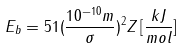Convert formula to latex. <formula><loc_0><loc_0><loc_500><loc_500>E _ { b } = 5 1 ( \frac { 1 0 ^ { - 1 0 } m } { \sigma } ) ^ { 2 } Z \, [ \frac { k J } { m o l } ]</formula> 